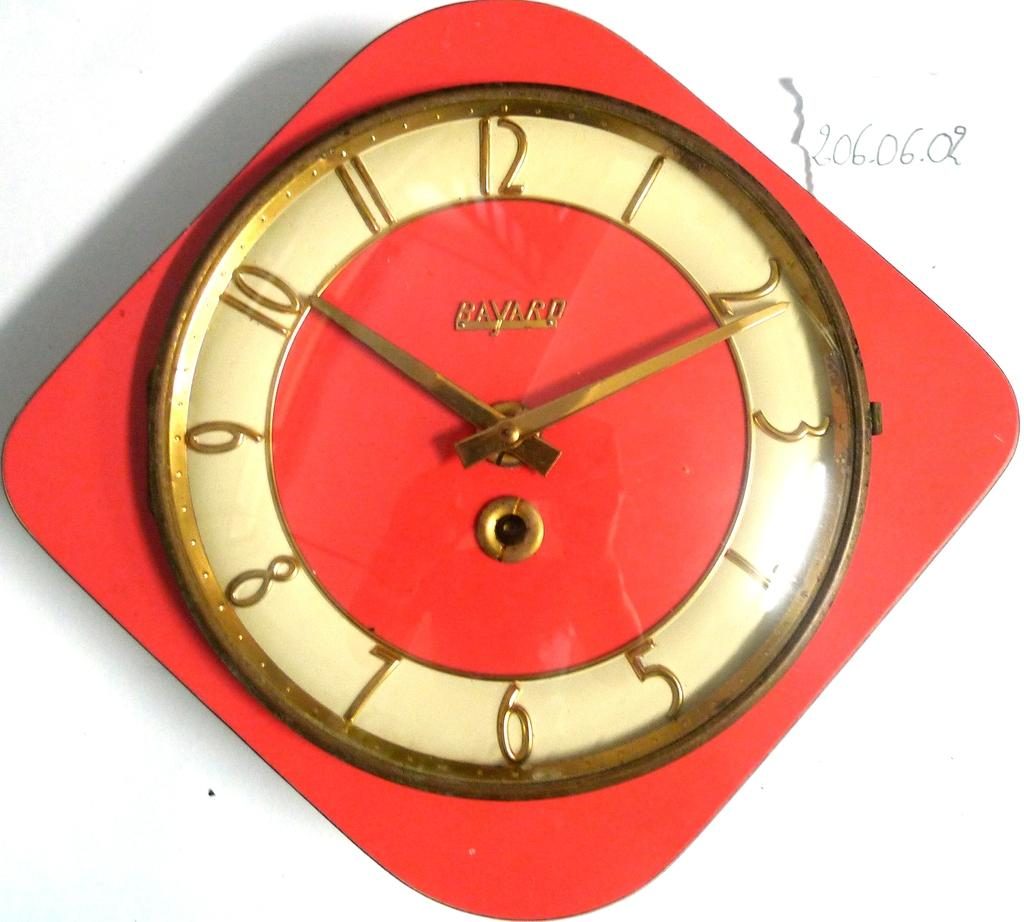What color is the clock in the image? The clock in the image is red. What color is the background of the image? The background of the image is white. What type of war is depicted in the image? There is no war depicted in the image; it features a red clock against a white background. Can you see a toad in the image? There is no toad present in the image. 